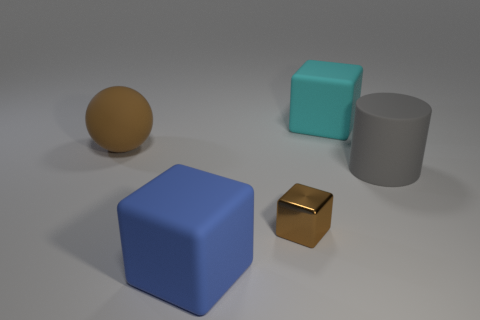The big thing that is both to the left of the tiny brown block and to the right of the rubber sphere is what color? The large object positioned to the left of the small brown block and to the right of the rubber sphere has a distinct blue color, with subtle shading indicating its 3D form and the lighting of the scene. 